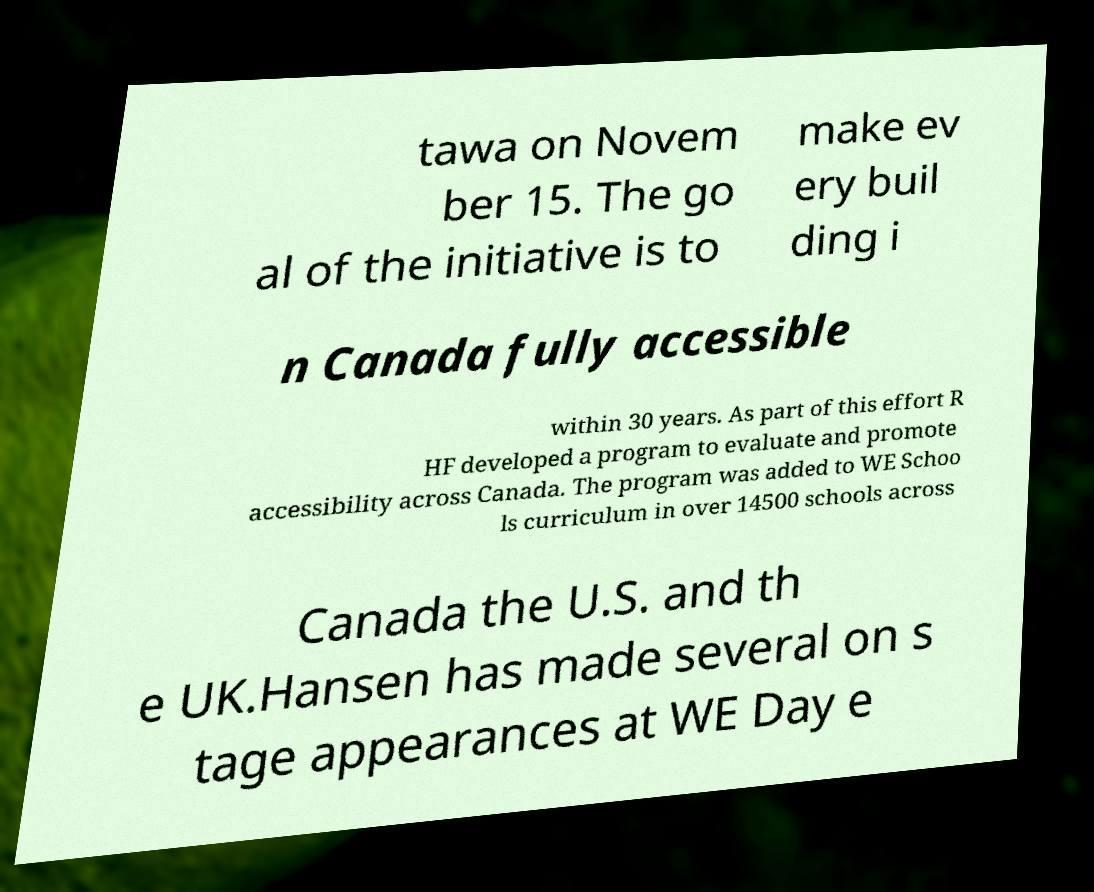Can you accurately transcribe the text from the provided image for me? tawa on Novem ber 15. The go al of the initiative is to make ev ery buil ding i n Canada fully accessible within 30 years. As part of this effort R HF developed a program to evaluate and promote accessibility across Canada. The program was added to WE Schoo ls curriculum in over 14500 schools across Canada the U.S. and th e UK.Hansen has made several on s tage appearances at WE Day e 